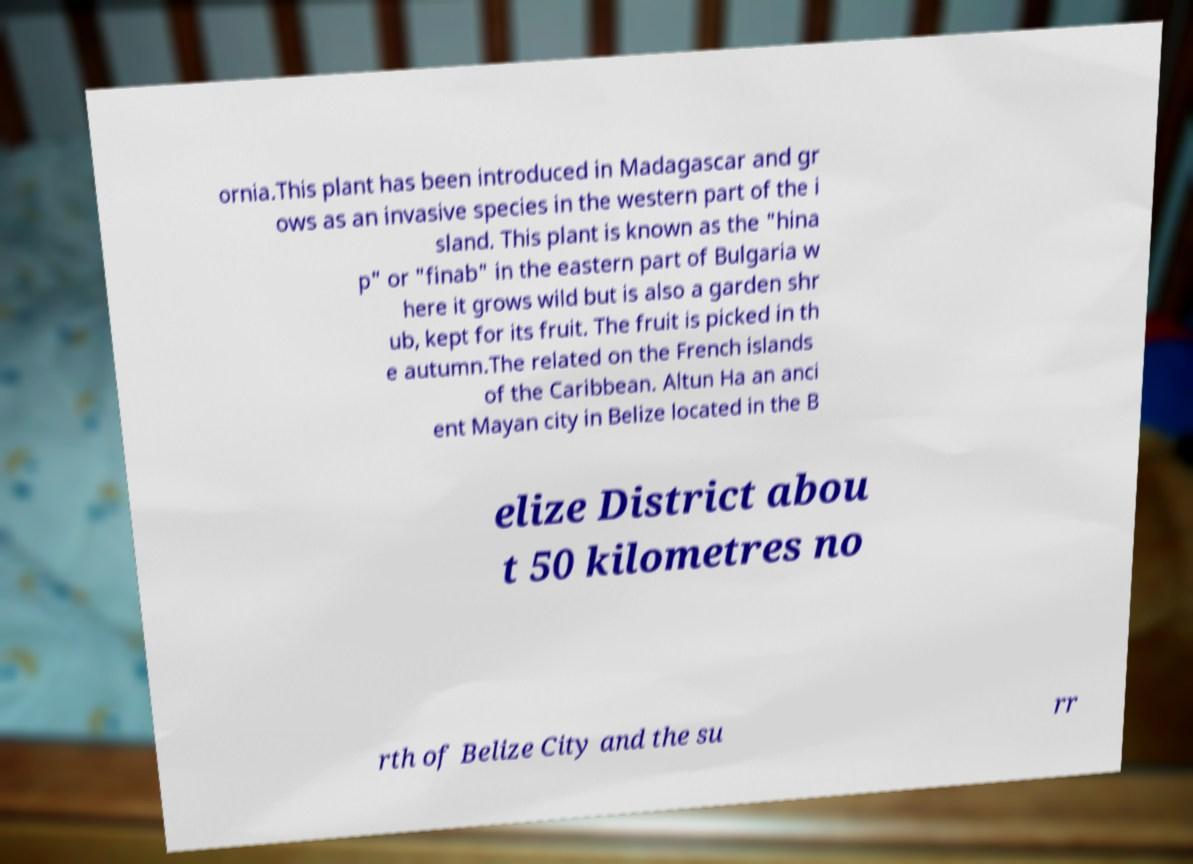Could you assist in decoding the text presented in this image and type it out clearly? ornia.This plant has been introduced in Madagascar and gr ows as an invasive species in the western part of the i sland. This plant is known as the "hina p" or "finab" in the eastern part of Bulgaria w here it grows wild but is also a garden shr ub, kept for its fruit. The fruit is picked in th e autumn.The related on the French islands of the Caribbean. Altun Ha an anci ent Mayan city in Belize located in the B elize District abou t 50 kilometres no rth of Belize City and the su rr 